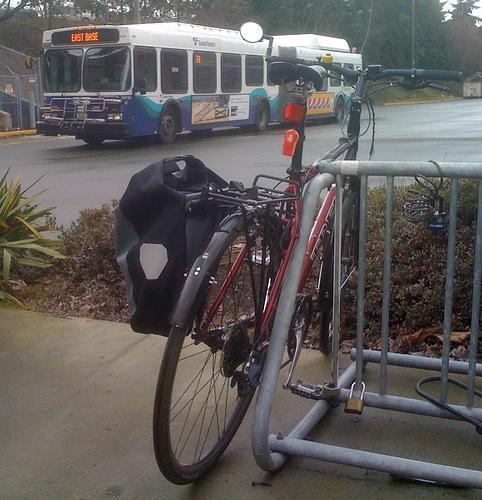How many hot dogs are there?
Give a very brief answer. 0. 